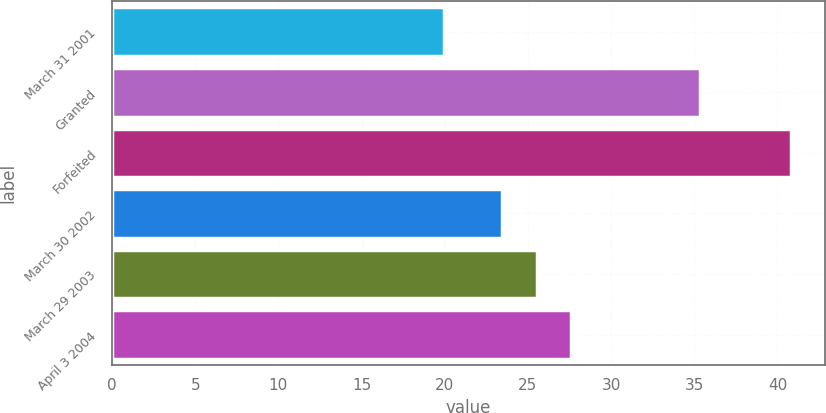Convert chart. <chart><loc_0><loc_0><loc_500><loc_500><bar_chart><fcel>March 31 2001<fcel>Granted<fcel>Forfeited<fcel>March 30 2002<fcel>March 29 2003<fcel>April 3 2004<nl><fcel>19.98<fcel>35.34<fcel>40.8<fcel>23.45<fcel>25.53<fcel>27.61<nl></chart> 